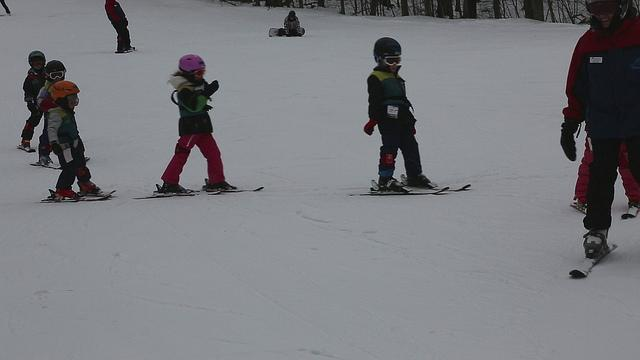What sort of lesson might the short people be getting? skiing 